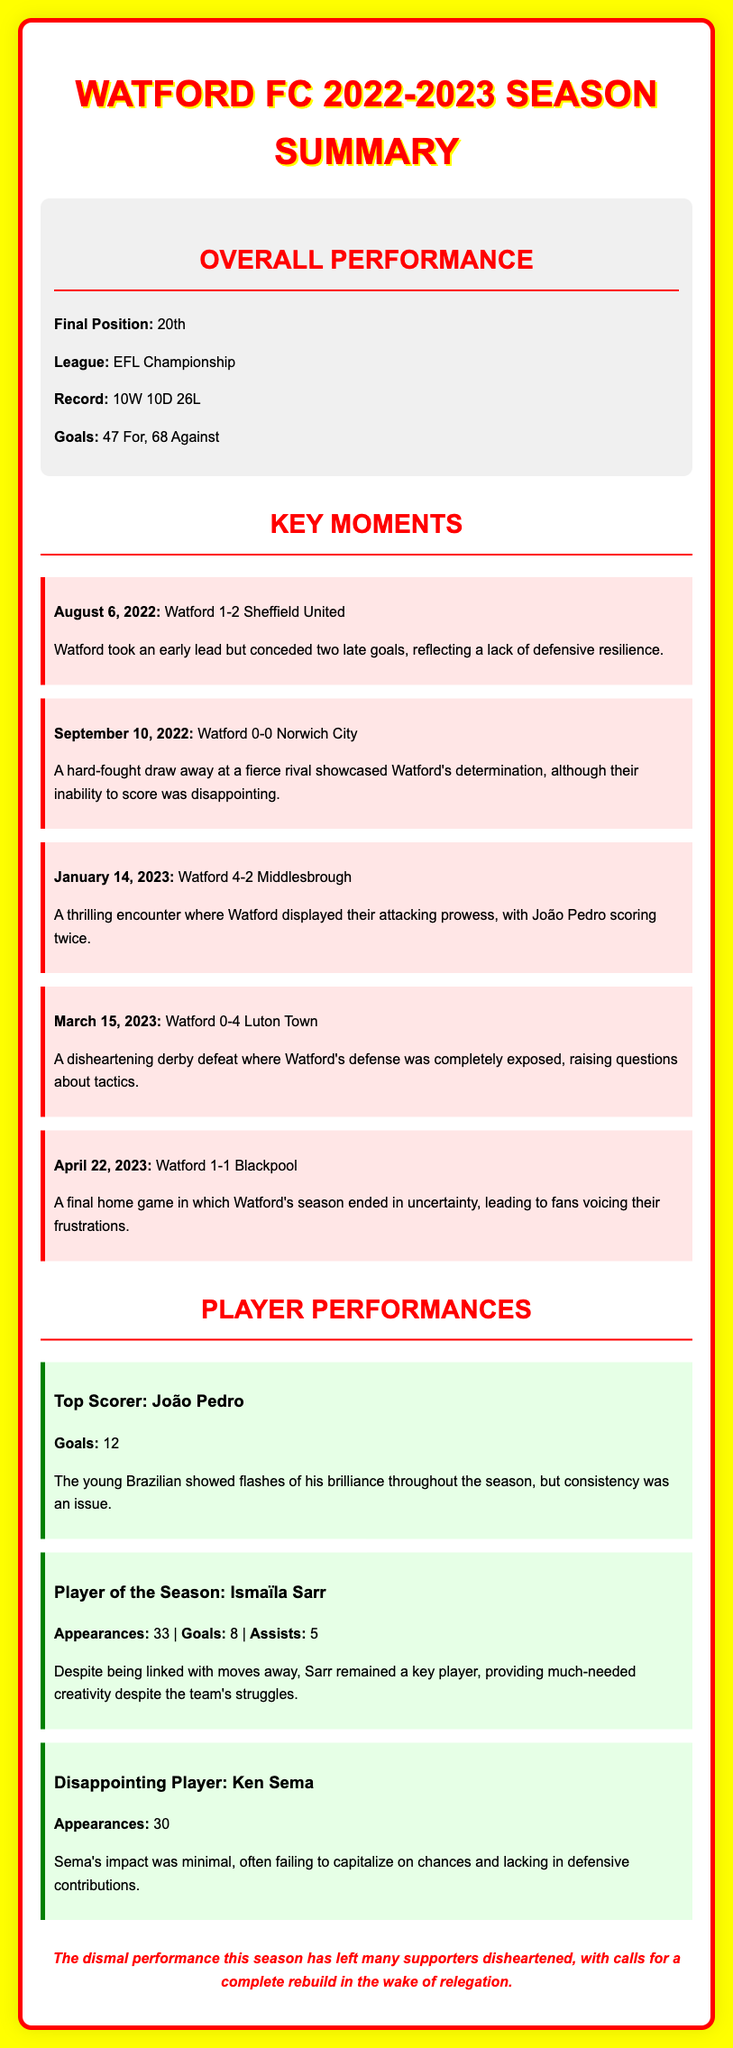what was Watford FC's final position in the league? The final position of Watford FC in the EFL Championship was 20th.
Answer: 20th how many wins did Watford FC achieve this season? The record shows Watford FC achieved 10 wins during the season.
Answer: 10 who was Watford FC's top scorer this season? The player's name credited with the most goals for Watford FC is João Pedro.
Answer: João Pedro how many goals did Ismaïla Sarr score? Ismaïla Sarr scored a total of 8 goals during the season.
Answer: 8 what was a key moment on March 15, 2023? On that date, Watford suffered a significant loss in a derby match against Luton Town.
Answer: 0-4 Luton Town how many goals did Watford concede during the season? The document states that Watford conceded 68 goals during the season.
Answer: 68 which player was highlighted as disappointing this season? Ken Sema is identified as the disappointing player for the season in the document.
Answer: Ken Sema what sentiment is expressed about the fans' feelings towards the team's performance? The document conveys that many supporters felt disheartened by the team's performance.
Answer: disheartened what was significant about the match on August 6, 2022? This match is notable as Watford took an early lead but eventually lost the game.
Answer: lost the game 